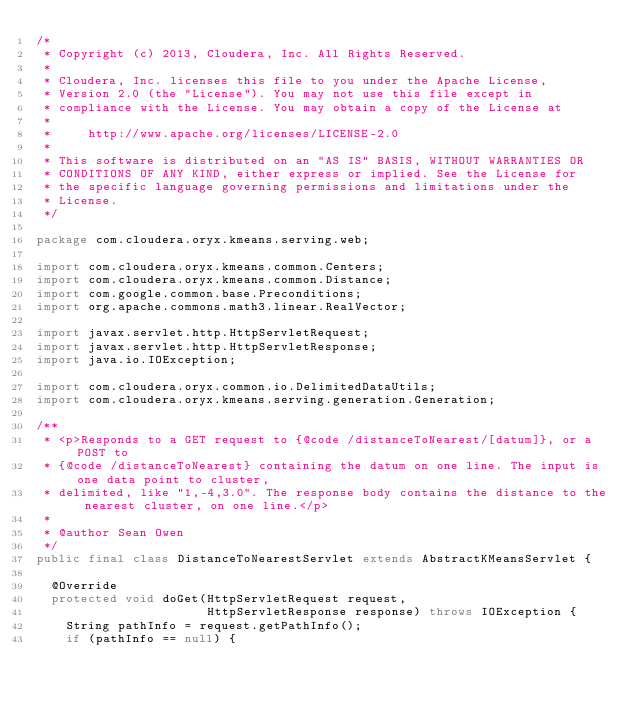<code> <loc_0><loc_0><loc_500><loc_500><_Java_>/*
 * Copyright (c) 2013, Cloudera, Inc. All Rights Reserved.
 *
 * Cloudera, Inc. licenses this file to you under the Apache License,
 * Version 2.0 (the "License"). You may not use this file except in
 * compliance with the License. You may obtain a copy of the License at
 *
 *     http://www.apache.org/licenses/LICENSE-2.0
 *
 * This software is distributed on an "AS IS" BASIS, WITHOUT WARRANTIES OR
 * CONDITIONS OF ANY KIND, either express or implied. See the License for
 * the specific language governing permissions and limitations under the
 * License.
 */

package com.cloudera.oryx.kmeans.serving.web;

import com.cloudera.oryx.kmeans.common.Centers;
import com.cloudera.oryx.kmeans.common.Distance;
import com.google.common.base.Preconditions;
import org.apache.commons.math3.linear.RealVector;

import javax.servlet.http.HttpServletRequest;
import javax.servlet.http.HttpServletResponse;
import java.io.IOException;

import com.cloudera.oryx.common.io.DelimitedDataUtils;
import com.cloudera.oryx.kmeans.serving.generation.Generation;

/**
 * <p>Responds to a GET request to {@code /distanceToNearest/[datum]}, or a POST to
 * {@code /distanceToNearest} containing the datum on one line. The input is one data point to cluster,
 * delimited, like "1,-4,3.0". The response body contains the distance to the nearest cluster, on one line.</p>
 *
 * @author Sean Owen
 */
public final class DistanceToNearestServlet extends AbstractKMeansServlet {

  @Override
  protected void doGet(HttpServletRequest request,
                       HttpServletResponse response) throws IOException {
    String pathInfo = request.getPathInfo();
    if (pathInfo == null) {</code> 